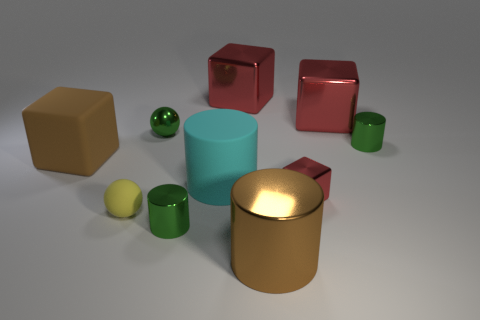What is the shape of the tiny green thing that is in front of the brown object behind the large brown object that is to the right of the small metallic sphere?
Give a very brief answer. Cylinder. What size is the yellow ball?
Your answer should be very brief. Small. Are there any brown things made of the same material as the tiny block?
Provide a succinct answer. Yes. There is another metal object that is the same shape as the yellow thing; what is its size?
Provide a succinct answer. Small. Are there an equal number of rubber spheres that are to the right of the yellow object and small yellow shiny cubes?
Offer a terse response. Yes. Does the brown thing on the right side of the large cyan cylinder have the same shape as the large cyan object?
Your answer should be very brief. Yes. There is a brown matte object; what shape is it?
Make the answer very short. Cube. There is a big brown object in front of the small green cylinder left of the green metallic object that is on the right side of the big cyan cylinder; what is its material?
Keep it short and to the point. Metal. There is a big cylinder that is the same color as the large matte cube; what material is it?
Keep it short and to the point. Metal. What number of things are either brown metallic cylinders or big red cubes?
Offer a very short reply. 3. 